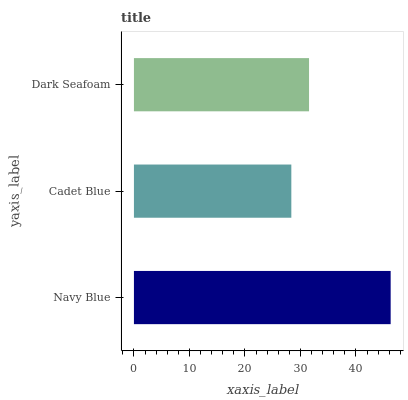Is Cadet Blue the minimum?
Answer yes or no. Yes. Is Navy Blue the maximum?
Answer yes or no. Yes. Is Dark Seafoam the minimum?
Answer yes or no. No. Is Dark Seafoam the maximum?
Answer yes or no. No. Is Dark Seafoam greater than Cadet Blue?
Answer yes or no. Yes. Is Cadet Blue less than Dark Seafoam?
Answer yes or no. Yes. Is Cadet Blue greater than Dark Seafoam?
Answer yes or no. No. Is Dark Seafoam less than Cadet Blue?
Answer yes or no. No. Is Dark Seafoam the high median?
Answer yes or no. Yes. Is Dark Seafoam the low median?
Answer yes or no. Yes. Is Navy Blue the high median?
Answer yes or no. No. Is Navy Blue the low median?
Answer yes or no. No. 